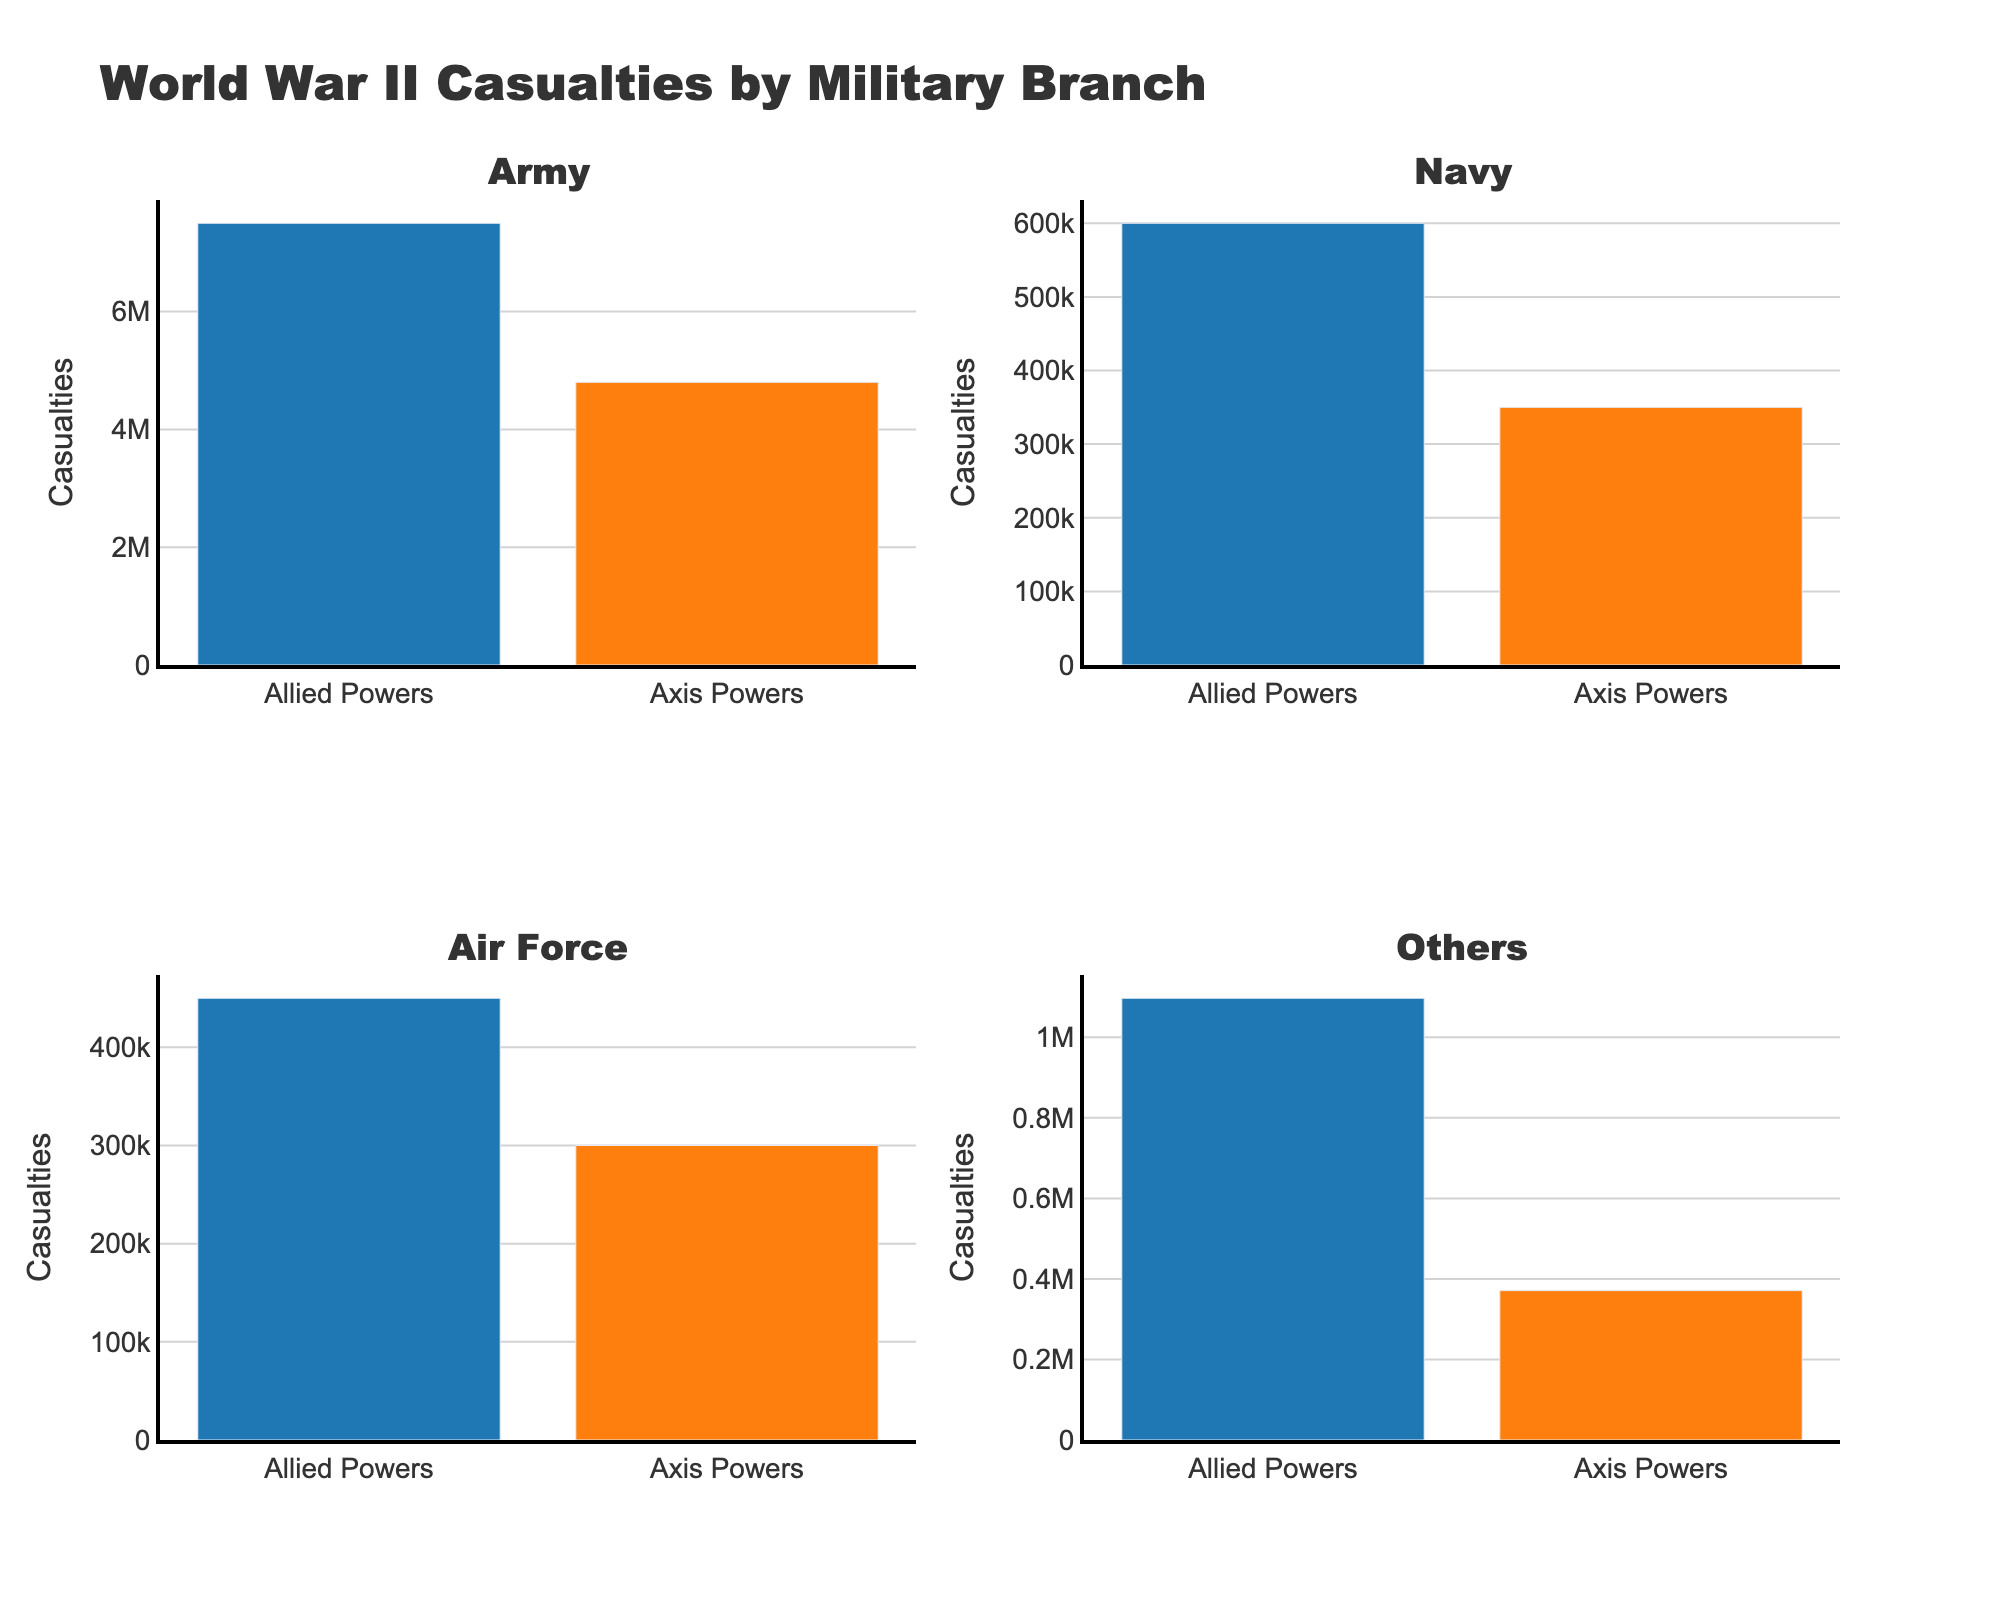what is the highest number of Allied Power casualties for a single military branch? The highest number is found in the 'Army' subplot. The bar representing Allied Power casualties for the Army is 7,500,000.
Answer: 7,500,000 Which military branch has the smallest difference in casualties between Allied and Axis Powers? The 'Coast Guard' has the smallest difference. Axis Powers casualties are 1,000, and Allied Powers casualties are 2,000. The difference is 1,000.
Answer: Coast Guard How many military branches are represented in the individual subplots? There are three subplots representing individual military branches: Army, Navy, and Air Force.
Answer: Three Which military branch among 'Others' has the highest casualties for Allied Powers? 'Resistance/Partisans' within the 'Others' section has the highest number of casualties for the Allied Powers, with 800,000.
Answer: Resistance/Partisans By how much do Army casualties exceed Navy casualties for the Allied Powers? The casualties for the Allied Powers Army are 7,500,000, and for the Navy, it is 600,000. The difference is 7,500,000 - 600,000 = 6,900,000.
Answer: 6,900,000 What is the total number of Axis Powers casualties represented across all military branches in the figure? Summing the Axis Powers casualties from Army (4,800,000), Navy (350,000), Air Force (300,000), and 'Others' (370,000): 4,800,000 + 350,000 + 300,000 + 370,000 = 5,820,000.
Answer: 5,820,000 Which subplot shows the most significant casualty difference between Allied and Axis Powers? The 'Army' subplot shows the most significant difference. Allied Power casualties are 7,500,000, and Axis Power casualties are 4,800,000. The difference is 2,700,000.
Answer: Army How many casualties are in the Air Force for both Allied and Axis Powers combined? The Allied Powers have 450,000, and the Axis Powers have 300,000 casualties in the Air Force. The total is 450,000 + 300,000 = 750,000.
Answer: 750,000 